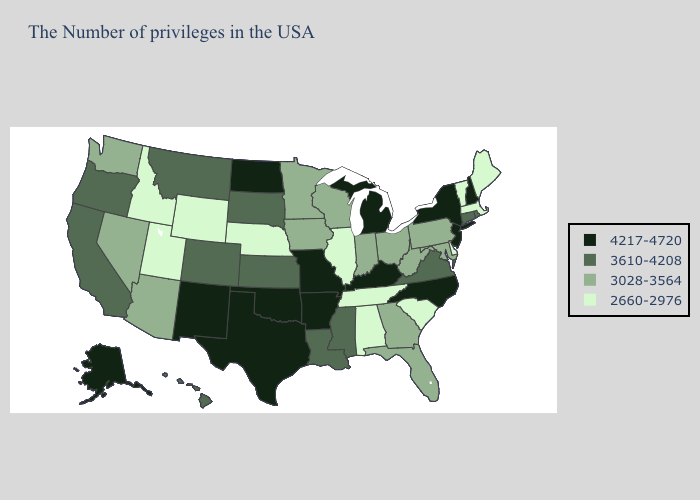Name the states that have a value in the range 4217-4720?
Answer briefly. New Hampshire, New York, New Jersey, North Carolina, Michigan, Kentucky, Missouri, Arkansas, Oklahoma, Texas, North Dakota, New Mexico, Alaska. Name the states that have a value in the range 2660-2976?
Concise answer only. Maine, Massachusetts, Vermont, Delaware, South Carolina, Alabama, Tennessee, Illinois, Nebraska, Wyoming, Utah, Idaho. What is the lowest value in states that border Nevada?
Keep it brief. 2660-2976. Does Michigan have the same value as Mississippi?
Give a very brief answer. No. Name the states that have a value in the range 3610-4208?
Keep it brief. Rhode Island, Connecticut, Virginia, Mississippi, Louisiana, Kansas, South Dakota, Colorado, Montana, California, Oregon, Hawaii. Does the first symbol in the legend represent the smallest category?
Write a very short answer. No. Does Vermont have the lowest value in the USA?
Keep it brief. Yes. Does Mississippi have the highest value in the USA?
Keep it brief. No. What is the value of Maine?
Answer briefly. 2660-2976. Name the states that have a value in the range 3610-4208?
Answer briefly. Rhode Island, Connecticut, Virginia, Mississippi, Louisiana, Kansas, South Dakota, Colorado, Montana, California, Oregon, Hawaii. Does Mississippi have a higher value than Pennsylvania?
Concise answer only. Yes. What is the value of Pennsylvania?
Write a very short answer. 3028-3564. What is the lowest value in the MidWest?
Short answer required. 2660-2976. Name the states that have a value in the range 3028-3564?
Keep it brief. Maryland, Pennsylvania, West Virginia, Ohio, Florida, Georgia, Indiana, Wisconsin, Minnesota, Iowa, Arizona, Nevada, Washington. What is the value of Maryland?
Keep it brief. 3028-3564. 